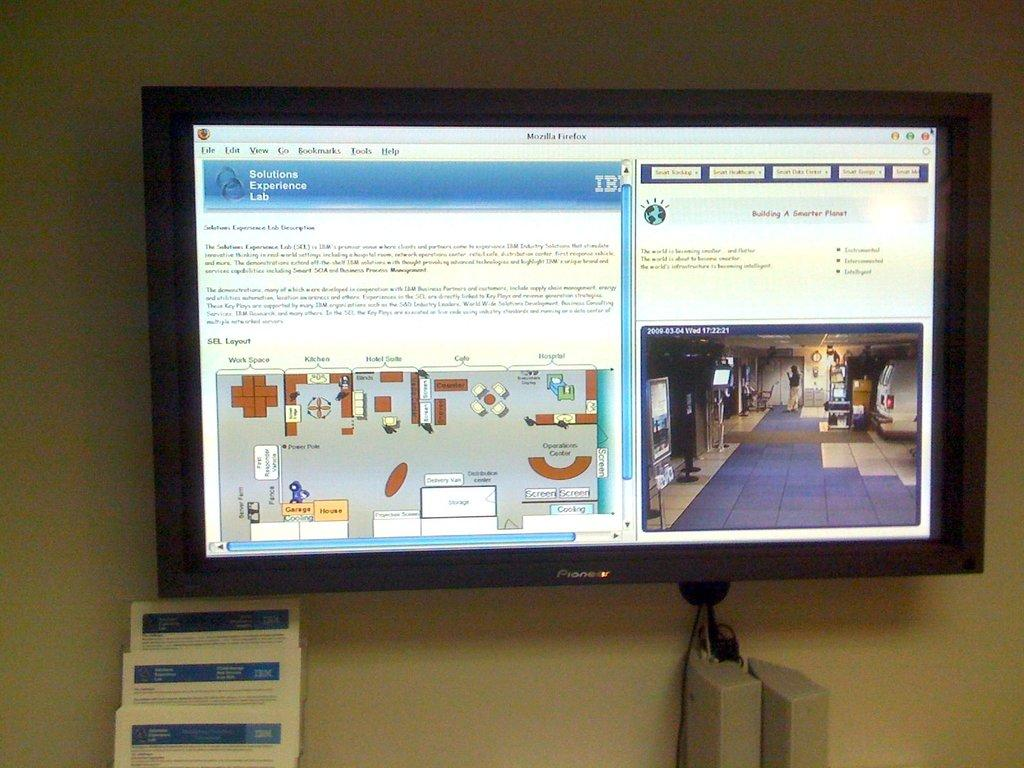<image>
Relay a brief, clear account of the picture shown. A Pioneer monitor is displaying a window from the Solutions Experience Lab. 